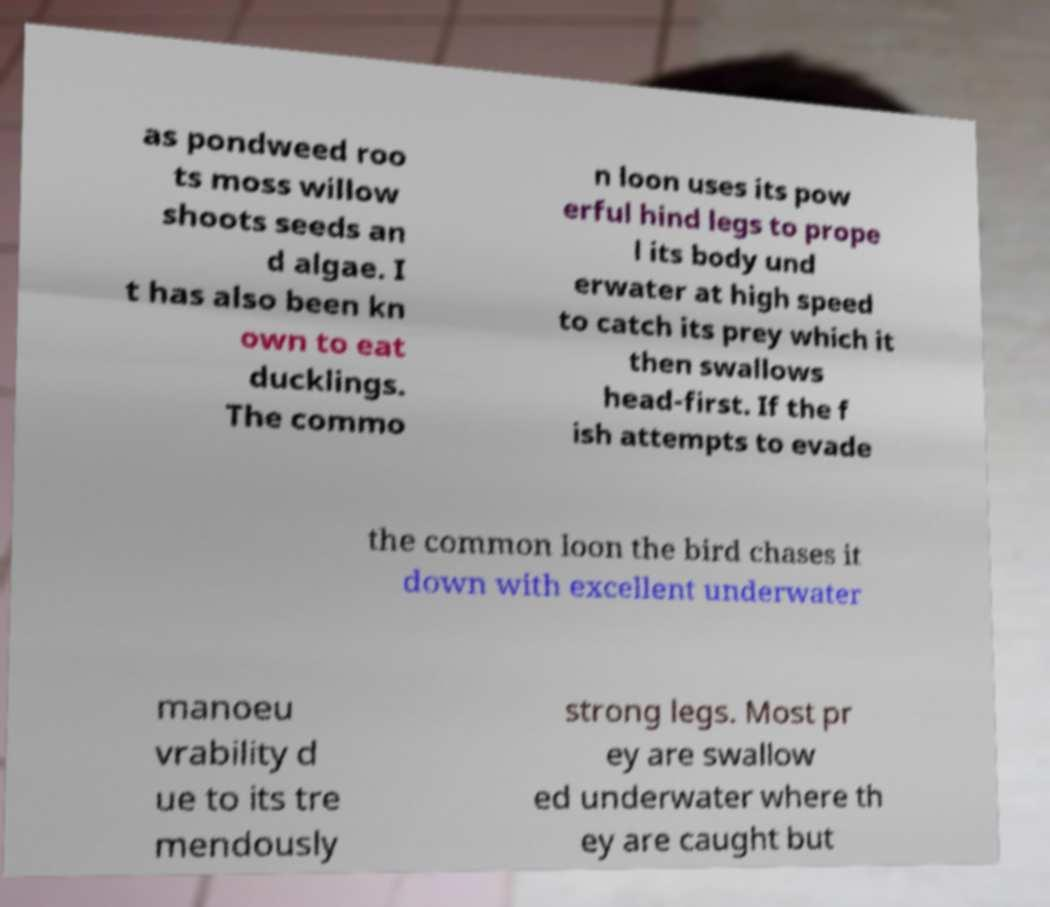I need the written content from this picture converted into text. Can you do that? as pondweed roo ts moss willow shoots seeds an d algae. I t has also been kn own to eat ducklings. The commo n loon uses its pow erful hind legs to prope l its body und erwater at high speed to catch its prey which it then swallows head-first. If the f ish attempts to evade the common loon the bird chases it down with excellent underwater manoeu vrability d ue to its tre mendously strong legs. Most pr ey are swallow ed underwater where th ey are caught but 